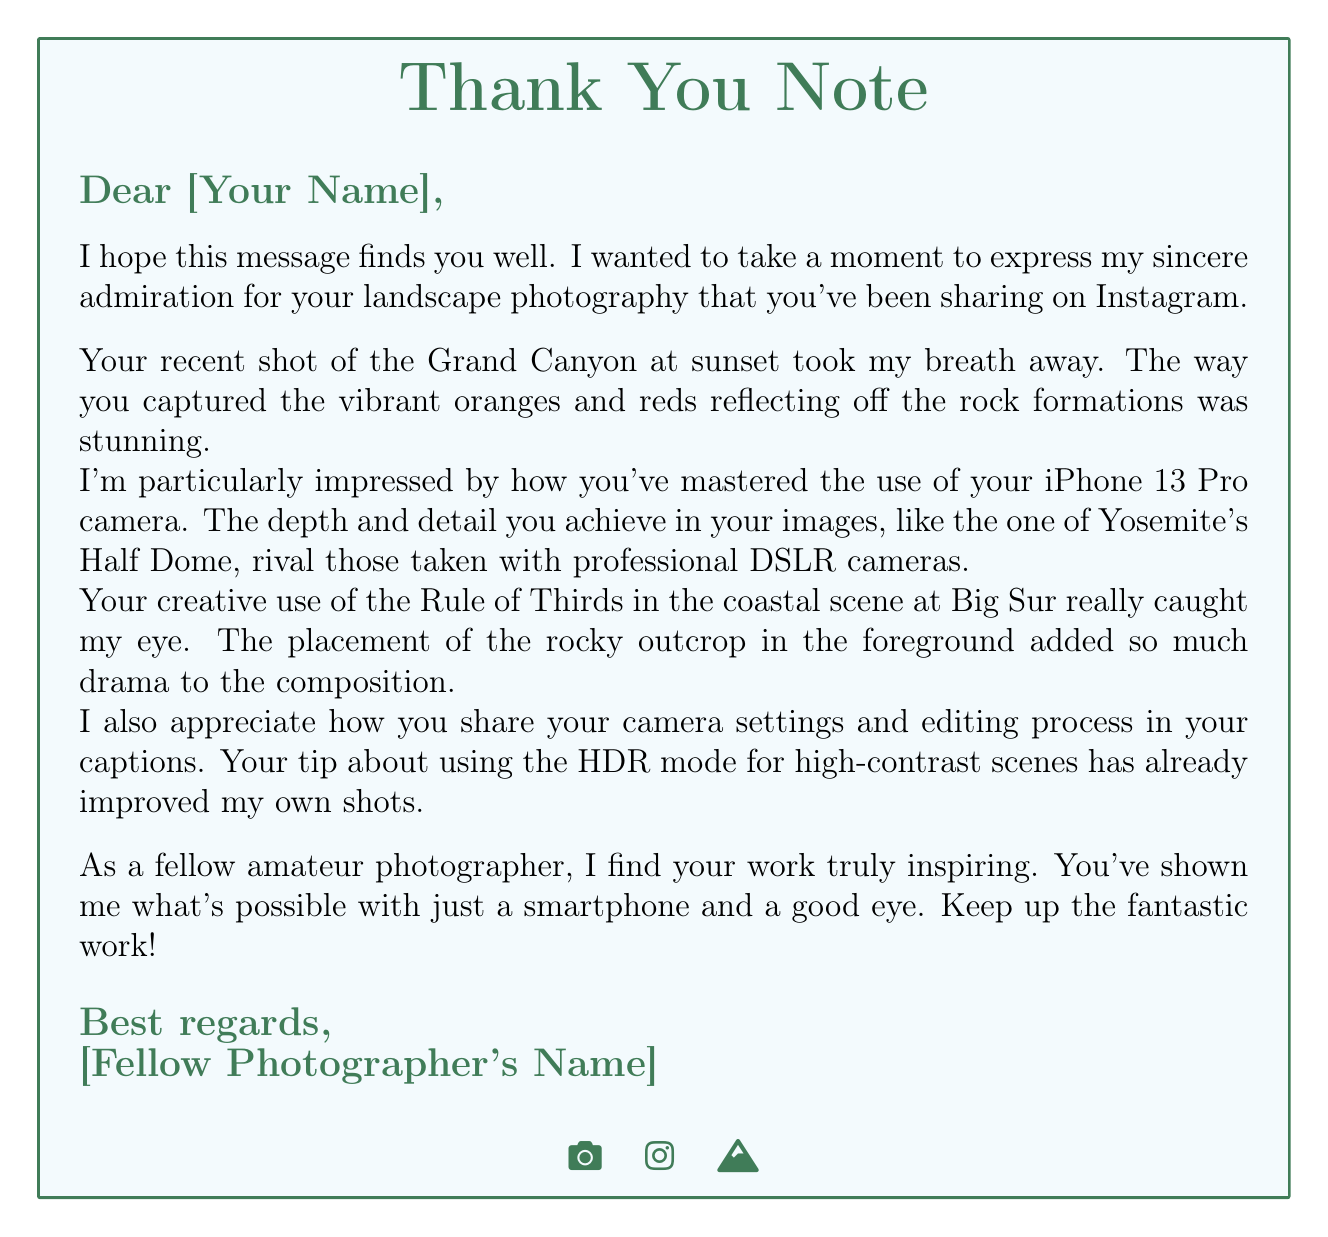What camera model was used? The document mentions the use of an iPhone 13 Pro for capturing landscape shots.
Answer: iPhone 13 Pro What social media platform is referenced? The letter highlights the sharing of photography on Instagram.
Answer: Instagram Which landscape location is mentioned first? The document lists the Grand Canyon National Park as the first location referenced in the letter.
Answer: Grand Canyon National Park What photography technique is specifically praised? The letter commends the use of the Rule of Thirds in the photographs.
Answer: Rule of Thirds How many followers were gained? The document states that 500 followers were gained along with the photography shares.
Answer: 500 What tip improved the letter writer's shots? The thank you note includes a tip about using HDR mode for enhancing images in high-contrast situations.
Answer: HDR mode How is the closing of the letter structured? The closing of the letter is signed off with respectful and encouraging remarks, emphasizing admiration.
Answer: Best regards What is one upcoming opportunity mentioned? The letter mentions a local smartphone photography workshop as an opportunity.
Answer: Local smartphone photography workshop What was one of the recent locations visited for photography? The letter lists Yosemite National Park as one of the recent photography locations.
Answer: Yosemite National Park 